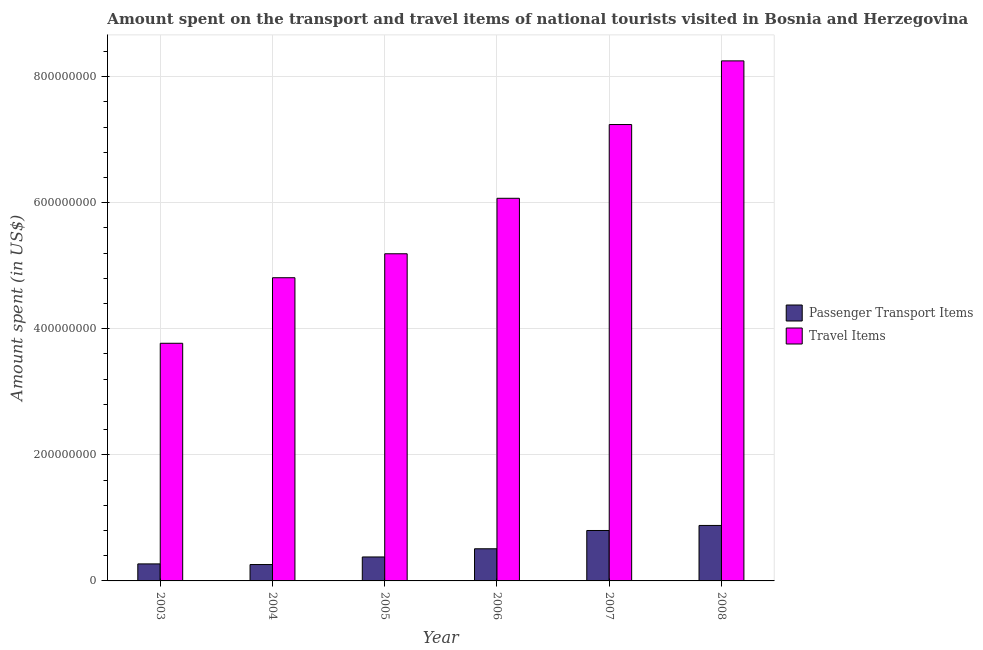How many different coloured bars are there?
Give a very brief answer. 2. How many groups of bars are there?
Your response must be concise. 6. Are the number of bars per tick equal to the number of legend labels?
Offer a very short reply. Yes. Are the number of bars on each tick of the X-axis equal?
Make the answer very short. Yes. How many bars are there on the 1st tick from the right?
Your answer should be very brief. 2. What is the label of the 2nd group of bars from the left?
Your response must be concise. 2004. In how many cases, is the number of bars for a given year not equal to the number of legend labels?
Your answer should be very brief. 0. What is the amount spent on passenger transport items in 2007?
Offer a terse response. 8.00e+07. Across all years, what is the maximum amount spent in travel items?
Keep it short and to the point. 8.25e+08. Across all years, what is the minimum amount spent in travel items?
Offer a very short reply. 3.77e+08. In which year was the amount spent in travel items maximum?
Ensure brevity in your answer.  2008. In which year was the amount spent on passenger transport items minimum?
Ensure brevity in your answer.  2004. What is the total amount spent in travel items in the graph?
Your answer should be compact. 3.53e+09. What is the difference between the amount spent in travel items in 2006 and that in 2008?
Offer a terse response. -2.18e+08. What is the difference between the amount spent on passenger transport items in 2006 and the amount spent in travel items in 2008?
Provide a short and direct response. -3.70e+07. What is the average amount spent on passenger transport items per year?
Ensure brevity in your answer.  5.17e+07. In how many years, is the amount spent on passenger transport items greater than 520000000 US$?
Offer a terse response. 0. What is the ratio of the amount spent in travel items in 2006 to that in 2008?
Keep it short and to the point. 0.74. Is the amount spent in travel items in 2005 less than that in 2007?
Keep it short and to the point. Yes. Is the difference between the amount spent on passenger transport items in 2005 and 2006 greater than the difference between the amount spent in travel items in 2005 and 2006?
Provide a succinct answer. No. What is the difference between the highest and the second highest amount spent in travel items?
Your answer should be very brief. 1.01e+08. What is the difference between the highest and the lowest amount spent in travel items?
Give a very brief answer. 4.48e+08. In how many years, is the amount spent in travel items greater than the average amount spent in travel items taken over all years?
Provide a short and direct response. 3. What does the 1st bar from the left in 2004 represents?
Make the answer very short. Passenger Transport Items. What does the 1st bar from the right in 2003 represents?
Offer a very short reply. Travel Items. Are all the bars in the graph horizontal?
Offer a very short reply. No. How many years are there in the graph?
Provide a succinct answer. 6. What is the difference between two consecutive major ticks on the Y-axis?
Offer a terse response. 2.00e+08. How many legend labels are there?
Offer a terse response. 2. What is the title of the graph?
Offer a very short reply. Amount spent on the transport and travel items of national tourists visited in Bosnia and Herzegovina. What is the label or title of the Y-axis?
Make the answer very short. Amount spent (in US$). What is the Amount spent (in US$) of Passenger Transport Items in 2003?
Your answer should be compact. 2.70e+07. What is the Amount spent (in US$) of Travel Items in 2003?
Make the answer very short. 3.77e+08. What is the Amount spent (in US$) of Passenger Transport Items in 2004?
Ensure brevity in your answer.  2.60e+07. What is the Amount spent (in US$) of Travel Items in 2004?
Ensure brevity in your answer.  4.81e+08. What is the Amount spent (in US$) in Passenger Transport Items in 2005?
Provide a short and direct response. 3.80e+07. What is the Amount spent (in US$) of Travel Items in 2005?
Your answer should be compact. 5.19e+08. What is the Amount spent (in US$) of Passenger Transport Items in 2006?
Give a very brief answer. 5.10e+07. What is the Amount spent (in US$) of Travel Items in 2006?
Give a very brief answer. 6.07e+08. What is the Amount spent (in US$) of Passenger Transport Items in 2007?
Your answer should be compact. 8.00e+07. What is the Amount spent (in US$) in Travel Items in 2007?
Provide a short and direct response. 7.24e+08. What is the Amount spent (in US$) in Passenger Transport Items in 2008?
Ensure brevity in your answer.  8.80e+07. What is the Amount spent (in US$) in Travel Items in 2008?
Provide a short and direct response. 8.25e+08. Across all years, what is the maximum Amount spent (in US$) in Passenger Transport Items?
Keep it short and to the point. 8.80e+07. Across all years, what is the maximum Amount spent (in US$) in Travel Items?
Your answer should be very brief. 8.25e+08. Across all years, what is the minimum Amount spent (in US$) in Passenger Transport Items?
Offer a very short reply. 2.60e+07. Across all years, what is the minimum Amount spent (in US$) of Travel Items?
Offer a terse response. 3.77e+08. What is the total Amount spent (in US$) in Passenger Transport Items in the graph?
Offer a terse response. 3.10e+08. What is the total Amount spent (in US$) of Travel Items in the graph?
Your answer should be compact. 3.53e+09. What is the difference between the Amount spent (in US$) of Travel Items in 2003 and that in 2004?
Offer a very short reply. -1.04e+08. What is the difference between the Amount spent (in US$) in Passenger Transport Items in 2003 and that in 2005?
Make the answer very short. -1.10e+07. What is the difference between the Amount spent (in US$) in Travel Items in 2003 and that in 2005?
Offer a terse response. -1.42e+08. What is the difference between the Amount spent (in US$) of Passenger Transport Items in 2003 and that in 2006?
Make the answer very short. -2.40e+07. What is the difference between the Amount spent (in US$) in Travel Items in 2003 and that in 2006?
Provide a short and direct response. -2.30e+08. What is the difference between the Amount spent (in US$) in Passenger Transport Items in 2003 and that in 2007?
Provide a succinct answer. -5.30e+07. What is the difference between the Amount spent (in US$) in Travel Items in 2003 and that in 2007?
Offer a terse response. -3.47e+08. What is the difference between the Amount spent (in US$) in Passenger Transport Items in 2003 and that in 2008?
Your answer should be compact. -6.10e+07. What is the difference between the Amount spent (in US$) in Travel Items in 2003 and that in 2008?
Provide a succinct answer. -4.48e+08. What is the difference between the Amount spent (in US$) of Passenger Transport Items in 2004 and that in 2005?
Your answer should be very brief. -1.20e+07. What is the difference between the Amount spent (in US$) in Travel Items in 2004 and that in 2005?
Keep it short and to the point. -3.80e+07. What is the difference between the Amount spent (in US$) in Passenger Transport Items in 2004 and that in 2006?
Offer a very short reply. -2.50e+07. What is the difference between the Amount spent (in US$) in Travel Items in 2004 and that in 2006?
Ensure brevity in your answer.  -1.26e+08. What is the difference between the Amount spent (in US$) of Passenger Transport Items in 2004 and that in 2007?
Keep it short and to the point. -5.40e+07. What is the difference between the Amount spent (in US$) in Travel Items in 2004 and that in 2007?
Ensure brevity in your answer.  -2.43e+08. What is the difference between the Amount spent (in US$) in Passenger Transport Items in 2004 and that in 2008?
Your answer should be very brief. -6.20e+07. What is the difference between the Amount spent (in US$) of Travel Items in 2004 and that in 2008?
Your response must be concise. -3.44e+08. What is the difference between the Amount spent (in US$) in Passenger Transport Items in 2005 and that in 2006?
Your response must be concise. -1.30e+07. What is the difference between the Amount spent (in US$) of Travel Items in 2005 and that in 2006?
Give a very brief answer. -8.80e+07. What is the difference between the Amount spent (in US$) of Passenger Transport Items in 2005 and that in 2007?
Your answer should be very brief. -4.20e+07. What is the difference between the Amount spent (in US$) in Travel Items in 2005 and that in 2007?
Your response must be concise. -2.05e+08. What is the difference between the Amount spent (in US$) in Passenger Transport Items in 2005 and that in 2008?
Your response must be concise. -5.00e+07. What is the difference between the Amount spent (in US$) of Travel Items in 2005 and that in 2008?
Offer a very short reply. -3.06e+08. What is the difference between the Amount spent (in US$) of Passenger Transport Items in 2006 and that in 2007?
Keep it short and to the point. -2.90e+07. What is the difference between the Amount spent (in US$) in Travel Items in 2006 and that in 2007?
Keep it short and to the point. -1.17e+08. What is the difference between the Amount spent (in US$) in Passenger Transport Items in 2006 and that in 2008?
Offer a terse response. -3.70e+07. What is the difference between the Amount spent (in US$) in Travel Items in 2006 and that in 2008?
Provide a short and direct response. -2.18e+08. What is the difference between the Amount spent (in US$) of Passenger Transport Items in 2007 and that in 2008?
Provide a short and direct response. -8.00e+06. What is the difference between the Amount spent (in US$) in Travel Items in 2007 and that in 2008?
Your answer should be compact. -1.01e+08. What is the difference between the Amount spent (in US$) of Passenger Transport Items in 2003 and the Amount spent (in US$) of Travel Items in 2004?
Offer a very short reply. -4.54e+08. What is the difference between the Amount spent (in US$) in Passenger Transport Items in 2003 and the Amount spent (in US$) in Travel Items in 2005?
Keep it short and to the point. -4.92e+08. What is the difference between the Amount spent (in US$) in Passenger Transport Items in 2003 and the Amount spent (in US$) in Travel Items in 2006?
Your response must be concise. -5.80e+08. What is the difference between the Amount spent (in US$) of Passenger Transport Items in 2003 and the Amount spent (in US$) of Travel Items in 2007?
Offer a very short reply. -6.97e+08. What is the difference between the Amount spent (in US$) in Passenger Transport Items in 2003 and the Amount spent (in US$) in Travel Items in 2008?
Your answer should be very brief. -7.98e+08. What is the difference between the Amount spent (in US$) in Passenger Transport Items in 2004 and the Amount spent (in US$) in Travel Items in 2005?
Offer a very short reply. -4.93e+08. What is the difference between the Amount spent (in US$) of Passenger Transport Items in 2004 and the Amount spent (in US$) of Travel Items in 2006?
Your answer should be very brief. -5.81e+08. What is the difference between the Amount spent (in US$) of Passenger Transport Items in 2004 and the Amount spent (in US$) of Travel Items in 2007?
Offer a terse response. -6.98e+08. What is the difference between the Amount spent (in US$) of Passenger Transport Items in 2004 and the Amount spent (in US$) of Travel Items in 2008?
Your answer should be very brief. -7.99e+08. What is the difference between the Amount spent (in US$) of Passenger Transport Items in 2005 and the Amount spent (in US$) of Travel Items in 2006?
Ensure brevity in your answer.  -5.69e+08. What is the difference between the Amount spent (in US$) in Passenger Transport Items in 2005 and the Amount spent (in US$) in Travel Items in 2007?
Your answer should be compact. -6.86e+08. What is the difference between the Amount spent (in US$) of Passenger Transport Items in 2005 and the Amount spent (in US$) of Travel Items in 2008?
Your answer should be very brief. -7.87e+08. What is the difference between the Amount spent (in US$) in Passenger Transport Items in 2006 and the Amount spent (in US$) in Travel Items in 2007?
Offer a very short reply. -6.73e+08. What is the difference between the Amount spent (in US$) of Passenger Transport Items in 2006 and the Amount spent (in US$) of Travel Items in 2008?
Keep it short and to the point. -7.74e+08. What is the difference between the Amount spent (in US$) of Passenger Transport Items in 2007 and the Amount spent (in US$) of Travel Items in 2008?
Keep it short and to the point. -7.45e+08. What is the average Amount spent (in US$) of Passenger Transport Items per year?
Provide a short and direct response. 5.17e+07. What is the average Amount spent (in US$) of Travel Items per year?
Keep it short and to the point. 5.89e+08. In the year 2003, what is the difference between the Amount spent (in US$) in Passenger Transport Items and Amount spent (in US$) in Travel Items?
Provide a short and direct response. -3.50e+08. In the year 2004, what is the difference between the Amount spent (in US$) of Passenger Transport Items and Amount spent (in US$) of Travel Items?
Provide a succinct answer. -4.55e+08. In the year 2005, what is the difference between the Amount spent (in US$) in Passenger Transport Items and Amount spent (in US$) in Travel Items?
Offer a terse response. -4.81e+08. In the year 2006, what is the difference between the Amount spent (in US$) in Passenger Transport Items and Amount spent (in US$) in Travel Items?
Keep it short and to the point. -5.56e+08. In the year 2007, what is the difference between the Amount spent (in US$) of Passenger Transport Items and Amount spent (in US$) of Travel Items?
Give a very brief answer. -6.44e+08. In the year 2008, what is the difference between the Amount spent (in US$) of Passenger Transport Items and Amount spent (in US$) of Travel Items?
Give a very brief answer. -7.37e+08. What is the ratio of the Amount spent (in US$) of Travel Items in 2003 to that in 2004?
Your answer should be very brief. 0.78. What is the ratio of the Amount spent (in US$) of Passenger Transport Items in 2003 to that in 2005?
Your answer should be compact. 0.71. What is the ratio of the Amount spent (in US$) of Travel Items in 2003 to that in 2005?
Offer a very short reply. 0.73. What is the ratio of the Amount spent (in US$) of Passenger Transport Items in 2003 to that in 2006?
Your answer should be very brief. 0.53. What is the ratio of the Amount spent (in US$) in Travel Items in 2003 to that in 2006?
Keep it short and to the point. 0.62. What is the ratio of the Amount spent (in US$) in Passenger Transport Items in 2003 to that in 2007?
Give a very brief answer. 0.34. What is the ratio of the Amount spent (in US$) in Travel Items in 2003 to that in 2007?
Your answer should be compact. 0.52. What is the ratio of the Amount spent (in US$) of Passenger Transport Items in 2003 to that in 2008?
Ensure brevity in your answer.  0.31. What is the ratio of the Amount spent (in US$) in Travel Items in 2003 to that in 2008?
Provide a succinct answer. 0.46. What is the ratio of the Amount spent (in US$) in Passenger Transport Items in 2004 to that in 2005?
Your answer should be compact. 0.68. What is the ratio of the Amount spent (in US$) in Travel Items in 2004 to that in 2005?
Offer a very short reply. 0.93. What is the ratio of the Amount spent (in US$) of Passenger Transport Items in 2004 to that in 2006?
Offer a terse response. 0.51. What is the ratio of the Amount spent (in US$) of Travel Items in 2004 to that in 2006?
Offer a terse response. 0.79. What is the ratio of the Amount spent (in US$) of Passenger Transport Items in 2004 to that in 2007?
Provide a short and direct response. 0.33. What is the ratio of the Amount spent (in US$) in Travel Items in 2004 to that in 2007?
Make the answer very short. 0.66. What is the ratio of the Amount spent (in US$) of Passenger Transport Items in 2004 to that in 2008?
Your response must be concise. 0.3. What is the ratio of the Amount spent (in US$) in Travel Items in 2004 to that in 2008?
Provide a short and direct response. 0.58. What is the ratio of the Amount spent (in US$) in Passenger Transport Items in 2005 to that in 2006?
Provide a succinct answer. 0.75. What is the ratio of the Amount spent (in US$) in Travel Items in 2005 to that in 2006?
Make the answer very short. 0.85. What is the ratio of the Amount spent (in US$) of Passenger Transport Items in 2005 to that in 2007?
Your answer should be very brief. 0.47. What is the ratio of the Amount spent (in US$) in Travel Items in 2005 to that in 2007?
Provide a succinct answer. 0.72. What is the ratio of the Amount spent (in US$) in Passenger Transport Items in 2005 to that in 2008?
Offer a very short reply. 0.43. What is the ratio of the Amount spent (in US$) in Travel Items in 2005 to that in 2008?
Offer a very short reply. 0.63. What is the ratio of the Amount spent (in US$) in Passenger Transport Items in 2006 to that in 2007?
Offer a very short reply. 0.64. What is the ratio of the Amount spent (in US$) of Travel Items in 2006 to that in 2007?
Provide a succinct answer. 0.84. What is the ratio of the Amount spent (in US$) in Passenger Transport Items in 2006 to that in 2008?
Provide a short and direct response. 0.58. What is the ratio of the Amount spent (in US$) in Travel Items in 2006 to that in 2008?
Your response must be concise. 0.74. What is the ratio of the Amount spent (in US$) in Passenger Transport Items in 2007 to that in 2008?
Ensure brevity in your answer.  0.91. What is the ratio of the Amount spent (in US$) in Travel Items in 2007 to that in 2008?
Keep it short and to the point. 0.88. What is the difference between the highest and the second highest Amount spent (in US$) of Passenger Transport Items?
Provide a succinct answer. 8.00e+06. What is the difference between the highest and the second highest Amount spent (in US$) in Travel Items?
Offer a very short reply. 1.01e+08. What is the difference between the highest and the lowest Amount spent (in US$) of Passenger Transport Items?
Offer a terse response. 6.20e+07. What is the difference between the highest and the lowest Amount spent (in US$) of Travel Items?
Your answer should be compact. 4.48e+08. 